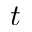Convert formula to latex. <formula><loc_0><loc_0><loc_500><loc_500>t</formula> 